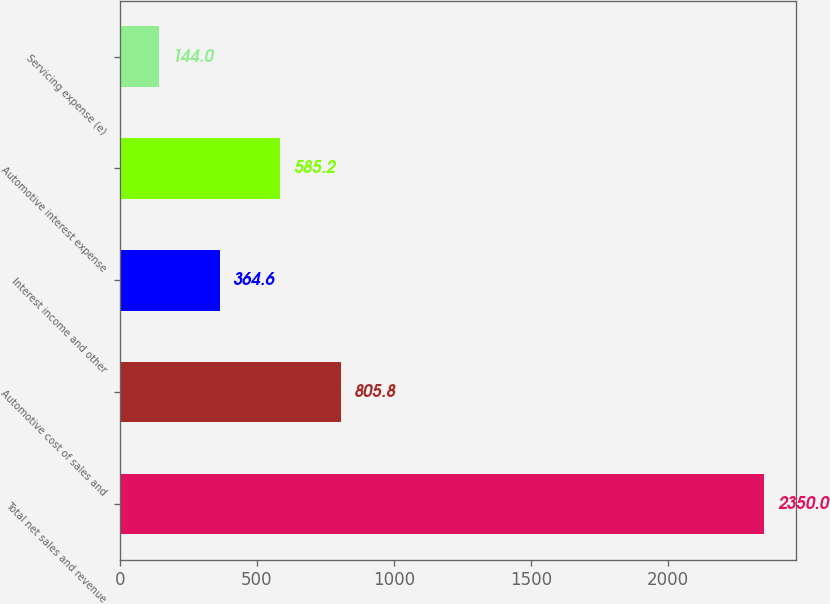<chart> <loc_0><loc_0><loc_500><loc_500><bar_chart><fcel>Total net sales and revenue<fcel>Automotive cost of sales and<fcel>Interest income and other<fcel>Automotive interest expense<fcel>Servicing expense (e)<nl><fcel>2350<fcel>805.8<fcel>364.6<fcel>585.2<fcel>144<nl></chart> 